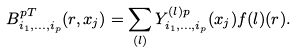<formula> <loc_0><loc_0><loc_500><loc_500>B ^ { p T } _ { i _ { 1 } , \dots , i _ { p } } ( r , x _ { j } ) = \sum _ { ( l ) } Y ^ { ( l ) p } _ { i _ { 1 } , \dots , i _ { p } } ( x _ { j } ) f { ( l ) } ( r ) .</formula> 